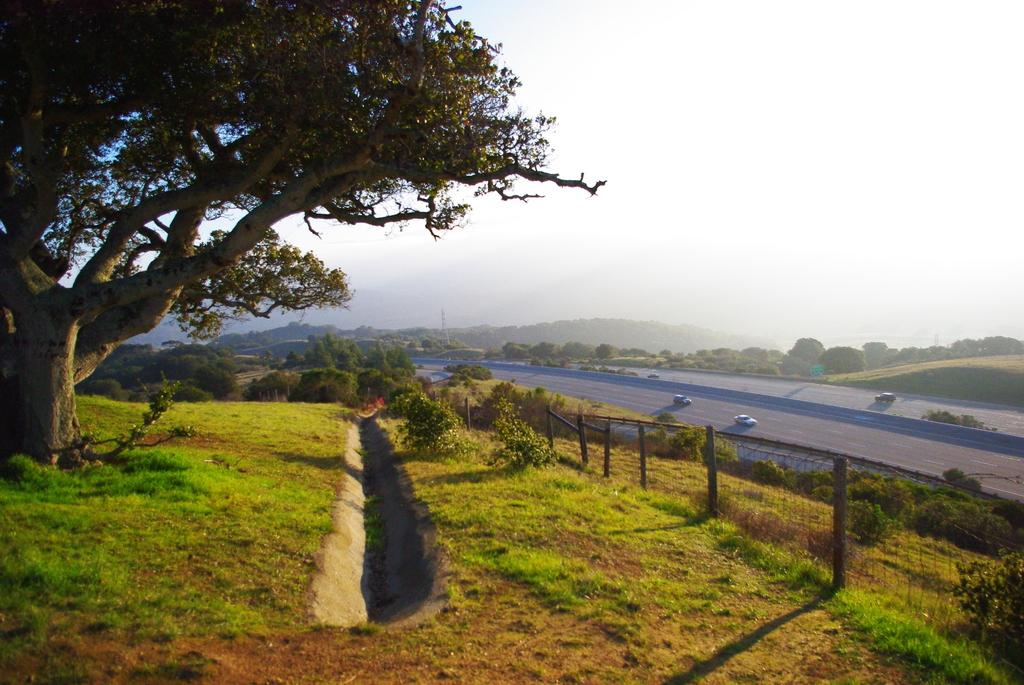What type of surface is visible in the image? There is ground in the image. What can be seen on the ground in the image? There is a road in the image. What type of vegetation is present in the image? There is grass, plants, and trees in the image. Can you describe the lighting in the image? Shadows are visible in the image, indicating that there is a light source. What else can be seen in the image? There are vehicles in the image. What type of popcorn is being served in the image? There is no popcorn present in the image. Is there a baby visible in the image? There is no baby present in the image. Can you tell me what brand of toothpaste is being advertised in the image? There is no toothpaste or advertisement present in the image. 